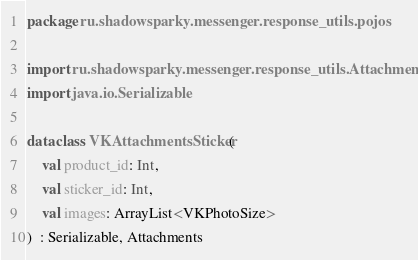Convert code to text. <code><loc_0><loc_0><loc_500><loc_500><_Kotlin_>package ru.shadowsparky.messenger.response_utils.pojos

import ru.shadowsparky.messenger.response_utils.Attachments
import java.io.Serializable

data class VKAttachmentsSticker(
    val product_id: Int,
    val sticker_id: Int,
    val images: ArrayList<VKPhotoSize>
)  : Serializable, Attachments</code> 